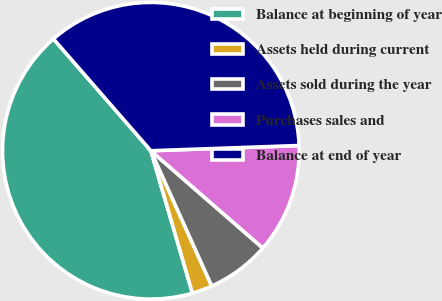Convert chart to OTSL. <chart><loc_0><loc_0><loc_500><loc_500><pie_chart><fcel>Balance at beginning of year<fcel>Assets held during current<fcel>Assets sold during the year<fcel>Purchases sales and<fcel>Balance at end of year<nl><fcel>43.12%<fcel>2.21%<fcel>6.88%<fcel>11.95%<fcel>35.84%<nl></chart> 